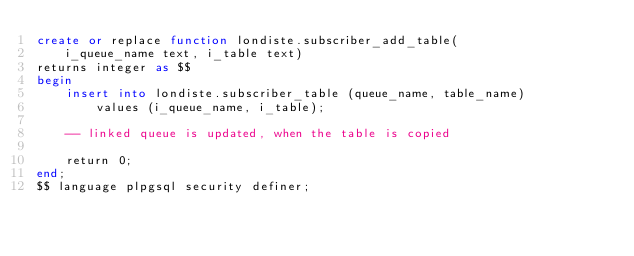<code> <loc_0><loc_0><loc_500><loc_500><_SQL_>create or replace function londiste.subscriber_add_table(
    i_queue_name text, i_table text)
returns integer as $$
begin
    insert into londiste.subscriber_table (queue_name, table_name)
        values (i_queue_name, i_table);

    -- linked queue is updated, when the table is copied

    return 0;
end;
$$ language plpgsql security definer;

</code> 